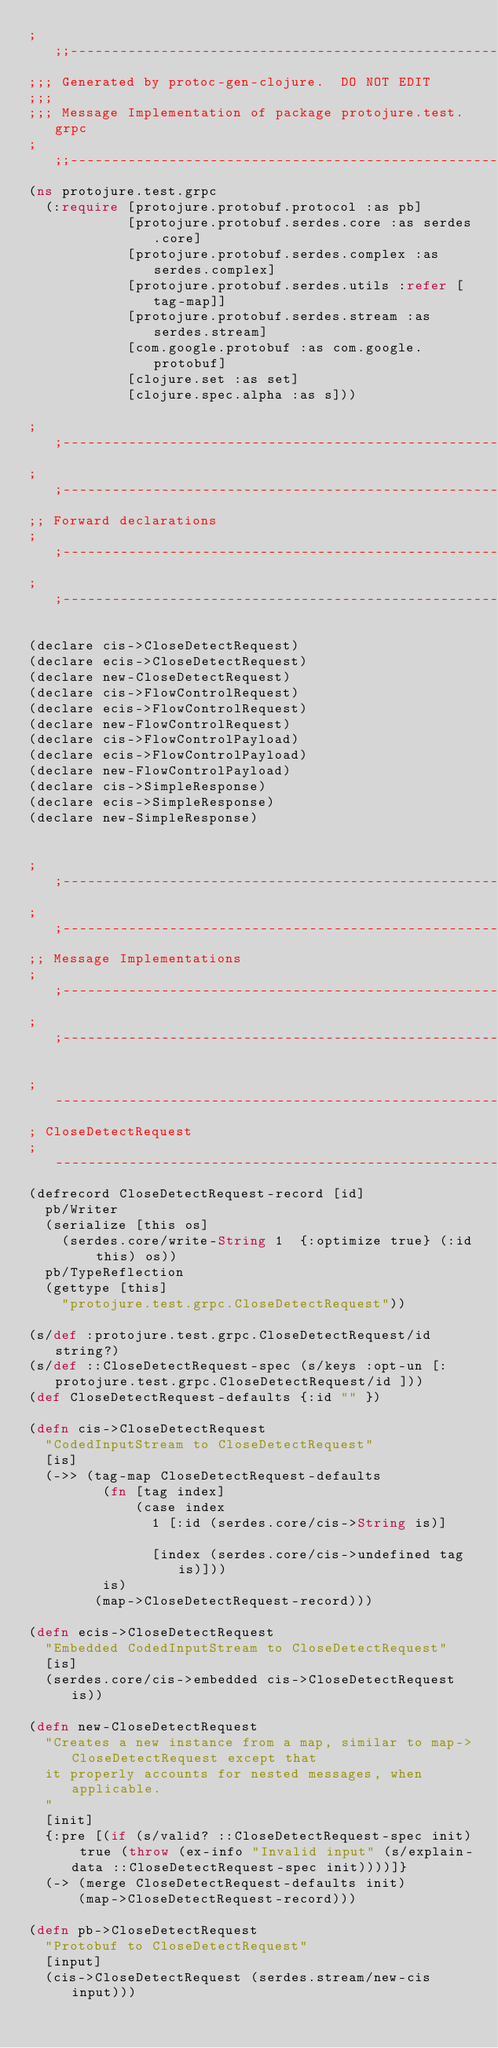Convert code to text. <code><loc_0><loc_0><loc_500><loc_500><_Clojure_>;;;----------------------------------------------------------------------------------
;;; Generated by protoc-gen-clojure.  DO NOT EDIT
;;;
;;; Message Implementation of package protojure.test.grpc
;;;----------------------------------------------------------------------------------
(ns protojure.test.grpc
  (:require [protojure.protobuf.protocol :as pb]
            [protojure.protobuf.serdes.core :as serdes.core]
            [protojure.protobuf.serdes.complex :as serdes.complex]
            [protojure.protobuf.serdes.utils :refer [tag-map]]
            [protojure.protobuf.serdes.stream :as serdes.stream]
            [com.google.protobuf :as com.google.protobuf]
            [clojure.set :as set]
            [clojure.spec.alpha :as s]))

;;----------------------------------------------------------------------------------
;;----------------------------------------------------------------------------------
;; Forward declarations
;;----------------------------------------------------------------------------------
;;----------------------------------------------------------------------------------

(declare cis->CloseDetectRequest)
(declare ecis->CloseDetectRequest)
(declare new-CloseDetectRequest)
(declare cis->FlowControlRequest)
(declare ecis->FlowControlRequest)
(declare new-FlowControlRequest)
(declare cis->FlowControlPayload)
(declare ecis->FlowControlPayload)
(declare new-FlowControlPayload)
(declare cis->SimpleResponse)
(declare ecis->SimpleResponse)
(declare new-SimpleResponse)


;;----------------------------------------------------------------------------------
;;----------------------------------------------------------------------------------
;; Message Implementations
;;----------------------------------------------------------------------------------
;;----------------------------------------------------------------------------------

;-----------------------------------------------------------------------------
; CloseDetectRequest
;-----------------------------------------------------------------------------
(defrecord CloseDetectRequest-record [id]
  pb/Writer
  (serialize [this os]
    (serdes.core/write-String 1  {:optimize true} (:id this) os))
  pb/TypeReflection
  (gettype [this]
    "protojure.test.grpc.CloseDetectRequest"))

(s/def :protojure.test.grpc.CloseDetectRequest/id string?)
(s/def ::CloseDetectRequest-spec (s/keys :opt-un [:protojure.test.grpc.CloseDetectRequest/id ]))
(def CloseDetectRequest-defaults {:id "" })

(defn cis->CloseDetectRequest
  "CodedInputStream to CloseDetectRequest"
  [is]
  (->> (tag-map CloseDetectRequest-defaults
         (fn [tag index]
             (case index
               1 [:id (serdes.core/cis->String is)]

               [index (serdes.core/cis->undefined tag is)]))
         is)
        (map->CloseDetectRequest-record)))

(defn ecis->CloseDetectRequest
  "Embedded CodedInputStream to CloseDetectRequest"
  [is]
  (serdes.core/cis->embedded cis->CloseDetectRequest is))

(defn new-CloseDetectRequest
  "Creates a new instance from a map, similar to map->CloseDetectRequest except that
  it properly accounts for nested messages, when applicable.
  "
  [init]
  {:pre [(if (s/valid? ::CloseDetectRequest-spec init) true (throw (ex-info "Invalid input" (s/explain-data ::CloseDetectRequest-spec init))))]}
  (-> (merge CloseDetectRequest-defaults init)
      (map->CloseDetectRequest-record)))

(defn pb->CloseDetectRequest
  "Protobuf to CloseDetectRequest"
  [input]
  (cis->CloseDetectRequest (serdes.stream/new-cis input)))
</code> 